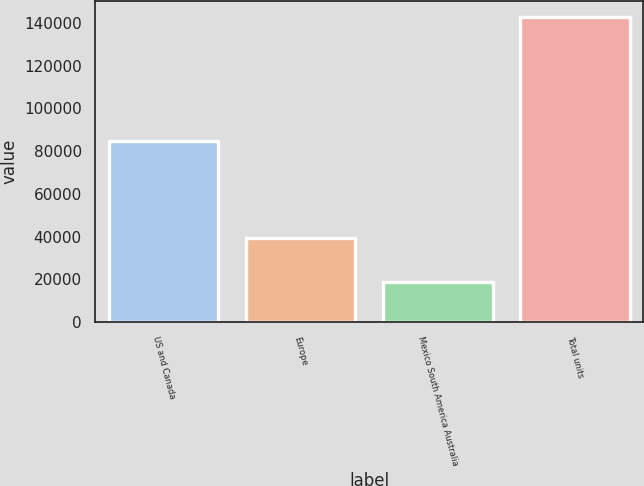<chart> <loc_0><loc_0><loc_500><loc_500><bar_chart><fcel>US and Canada<fcel>Europe<fcel>Mexico South America Australia<fcel>Total units<nl><fcel>84800<fcel>39500<fcel>18600<fcel>142900<nl></chart> 